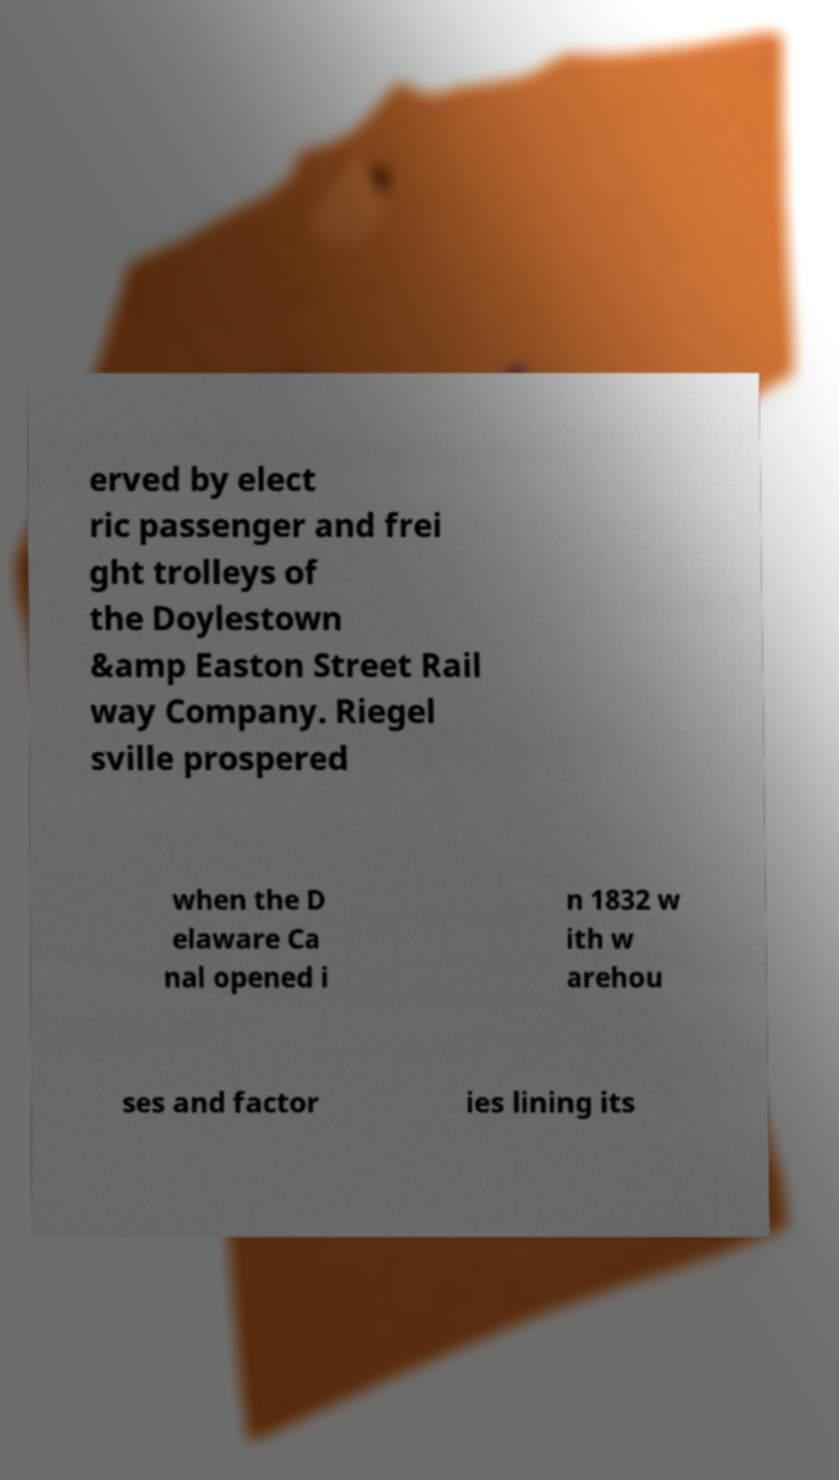I need the written content from this picture converted into text. Can you do that? erved by elect ric passenger and frei ght trolleys of the Doylestown &amp Easton Street Rail way Company. Riegel sville prospered when the D elaware Ca nal opened i n 1832 w ith w arehou ses and factor ies lining its 